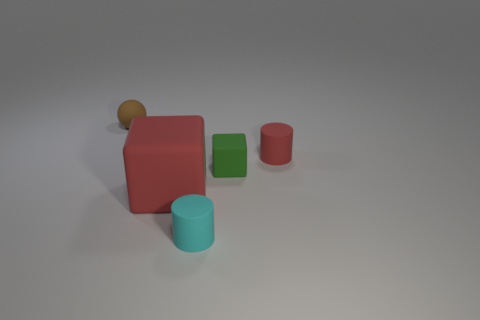Add 3 tiny rubber cylinders. How many objects exist? 8 Subtract all cubes. How many objects are left? 3 Add 1 red rubber objects. How many red rubber objects are left? 3 Add 4 small brown objects. How many small brown objects exist? 5 Subtract 0 gray balls. How many objects are left? 5 Subtract all small red cylinders. Subtract all cubes. How many objects are left? 2 